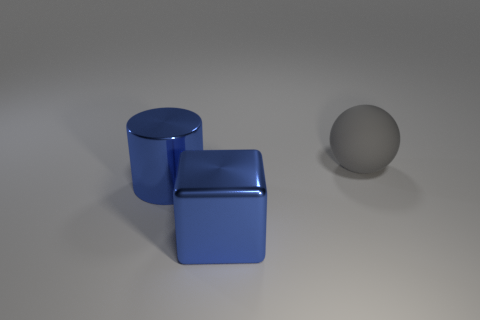How are the shadows in the image oriented in relation to the light source? The shadows in the image extend towards the bottom right, indicating that the light source is positioned towards the top left of the scene. 